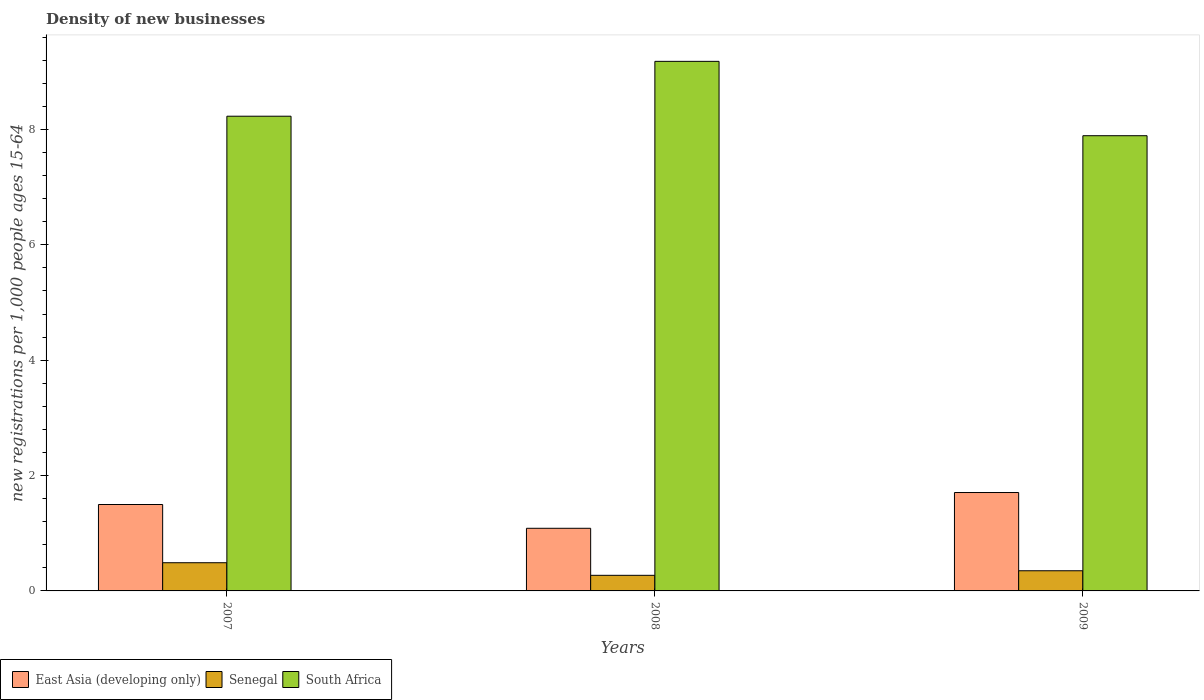How many groups of bars are there?
Offer a terse response. 3. Are the number of bars per tick equal to the number of legend labels?
Your answer should be compact. Yes. How many bars are there on the 3rd tick from the right?
Provide a succinct answer. 3. What is the label of the 3rd group of bars from the left?
Give a very brief answer. 2009. In how many cases, is the number of bars for a given year not equal to the number of legend labels?
Ensure brevity in your answer.  0. What is the number of new registrations in South Africa in 2007?
Keep it short and to the point. 8.23. Across all years, what is the maximum number of new registrations in Senegal?
Provide a short and direct response. 0.49. Across all years, what is the minimum number of new registrations in East Asia (developing only)?
Your answer should be very brief. 1.09. In which year was the number of new registrations in East Asia (developing only) maximum?
Give a very brief answer. 2009. What is the total number of new registrations in East Asia (developing only) in the graph?
Make the answer very short. 4.29. What is the difference between the number of new registrations in Senegal in 2008 and that in 2009?
Your answer should be very brief. -0.08. What is the difference between the number of new registrations in East Asia (developing only) in 2008 and the number of new registrations in Senegal in 2009?
Offer a terse response. 0.74. What is the average number of new registrations in East Asia (developing only) per year?
Provide a short and direct response. 1.43. In the year 2008, what is the difference between the number of new registrations in Senegal and number of new registrations in East Asia (developing only)?
Offer a terse response. -0.82. What is the ratio of the number of new registrations in South Africa in 2007 to that in 2008?
Your response must be concise. 0.9. Is the difference between the number of new registrations in Senegal in 2007 and 2008 greater than the difference between the number of new registrations in East Asia (developing only) in 2007 and 2008?
Ensure brevity in your answer.  No. What is the difference between the highest and the second highest number of new registrations in East Asia (developing only)?
Make the answer very short. 0.21. What is the difference between the highest and the lowest number of new registrations in East Asia (developing only)?
Your answer should be compact. 0.62. In how many years, is the number of new registrations in South Africa greater than the average number of new registrations in South Africa taken over all years?
Your response must be concise. 1. What does the 1st bar from the left in 2007 represents?
Your response must be concise. East Asia (developing only). What does the 3rd bar from the right in 2007 represents?
Provide a succinct answer. East Asia (developing only). Are all the bars in the graph horizontal?
Your answer should be compact. No. How many years are there in the graph?
Keep it short and to the point. 3. What is the difference between two consecutive major ticks on the Y-axis?
Provide a succinct answer. 2. Does the graph contain grids?
Provide a short and direct response. No. Where does the legend appear in the graph?
Provide a short and direct response. Bottom left. How many legend labels are there?
Provide a short and direct response. 3. What is the title of the graph?
Give a very brief answer. Density of new businesses. Does "Ukraine" appear as one of the legend labels in the graph?
Give a very brief answer. No. What is the label or title of the X-axis?
Give a very brief answer. Years. What is the label or title of the Y-axis?
Keep it short and to the point. New registrations per 1,0 people ages 15-64. What is the new registrations per 1,000 people ages 15-64 in East Asia (developing only) in 2007?
Give a very brief answer. 1.5. What is the new registrations per 1,000 people ages 15-64 in Senegal in 2007?
Provide a succinct answer. 0.49. What is the new registrations per 1,000 people ages 15-64 of South Africa in 2007?
Your answer should be compact. 8.23. What is the new registrations per 1,000 people ages 15-64 of East Asia (developing only) in 2008?
Provide a succinct answer. 1.09. What is the new registrations per 1,000 people ages 15-64 of Senegal in 2008?
Give a very brief answer. 0.27. What is the new registrations per 1,000 people ages 15-64 in South Africa in 2008?
Your answer should be very brief. 9.18. What is the new registrations per 1,000 people ages 15-64 of East Asia (developing only) in 2009?
Provide a succinct answer. 1.71. What is the new registrations per 1,000 people ages 15-64 of Senegal in 2009?
Keep it short and to the point. 0.35. What is the new registrations per 1,000 people ages 15-64 of South Africa in 2009?
Ensure brevity in your answer.  7.89. Across all years, what is the maximum new registrations per 1,000 people ages 15-64 in East Asia (developing only)?
Provide a short and direct response. 1.71. Across all years, what is the maximum new registrations per 1,000 people ages 15-64 in Senegal?
Keep it short and to the point. 0.49. Across all years, what is the maximum new registrations per 1,000 people ages 15-64 in South Africa?
Give a very brief answer. 9.18. Across all years, what is the minimum new registrations per 1,000 people ages 15-64 of East Asia (developing only)?
Your response must be concise. 1.09. Across all years, what is the minimum new registrations per 1,000 people ages 15-64 of Senegal?
Give a very brief answer. 0.27. Across all years, what is the minimum new registrations per 1,000 people ages 15-64 of South Africa?
Your answer should be compact. 7.89. What is the total new registrations per 1,000 people ages 15-64 in East Asia (developing only) in the graph?
Your answer should be very brief. 4.29. What is the total new registrations per 1,000 people ages 15-64 of Senegal in the graph?
Give a very brief answer. 1.11. What is the total new registrations per 1,000 people ages 15-64 in South Africa in the graph?
Make the answer very short. 25.3. What is the difference between the new registrations per 1,000 people ages 15-64 of East Asia (developing only) in 2007 and that in 2008?
Your response must be concise. 0.41. What is the difference between the new registrations per 1,000 people ages 15-64 of Senegal in 2007 and that in 2008?
Offer a very short reply. 0.22. What is the difference between the new registrations per 1,000 people ages 15-64 of South Africa in 2007 and that in 2008?
Your answer should be compact. -0.95. What is the difference between the new registrations per 1,000 people ages 15-64 in East Asia (developing only) in 2007 and that in 2009?
Offer a very short reply. -0.21. What is the difference between the new registrations per 1,000 people ages 15-64 in Senegal in 2007 and that in 2009?
Your answer should be very brief. 0.14. What is the difference between the new registrations per 1,000 people ages 15-64 of South Africa in 2007 and that in 2009?
Provide a succinct answer. 0.34. What is the difference between the new registrations per 1,000 people ages 15-64 of East Asia (developing only) in 2008 and that in 2009?
Ensure brevity in your answer.  -0.62. What is the difference between the new registrations per 1,000 people ages 15-64 of Senegal in 2008 and that in 2009?
Give a very brief answer. -0.08. What is the difference between the new registrations per 1,000 people ages 15-64 in South Africa in 2008 and that in 2009?
Provide a short and direct response. 1.29. What is the difference between the new registrations per 1,000 people ages 15-64 of East Asia (developing only) in 2007 and the new registrations per 1,000 people ages 15-64 of Senegal in 2008?
Your answer should be compact. 1.23. What is the difference between the new registrations per 1,000 people ages 15-64 of East Asia (developing only) in 2007 and the new registrations per 1,000 people ages 15-64 of South Africa in 2008?
Ensure brevity in your answer.  -7.68. What is the difference between the new registrations per 1,000 people ages 15-64 in Senegal in 2007 and the new registrations per 1,000 people ages 15-64 in South Africa in 2008?
Provide a short and direct response. -8.69. What is the difference between the new registrations per 1,000 people ages 15-64 of East Asia (developing only) in 2007 and the new registrations per 1,000 people ages 15-64 of Senegal in 2009?
Offer a terse response. 1.15. What is the difference between the new registrations per 1,000 people ages 15-64 in East Asia (developing only) in 2007 and the new registrations per 1,000 people ages 15-64 in South Africa in 2009?
Keep it short and to the point. -6.39. What is the difference between the new registrations per 1,000 people ages 15-64 of Senegal in 2007 and the new registrations per 1,000 people ages 15-64 of South Africa in 2009?
Your answer should be compact. -7.4. What is the difference between the new registrations per 1,000 people ages 15-64 of East Asia (developing only) in 2008 and the new registrations per 1,000 people ages 15-64 of Senegal in 2009?
Keep it short and to the point. 0.74. What is the difference between the new registrations per 1,000 people ages 15-64 in East Asia (developing only) in 2008 and the new registrations per 1,000 people ages 15-64 in South Africa in 2009?
Give a very brief answer. -6.81. What is the difference between the new registrations per 1,000 people ages 15-64 of Senegal in 2008 and the new registrations per 1,000 people ages 15-64 of South Africa in 2009?
Provide a short and direct response. -7.62. What is the average new registrations per 1,000 people ages 15-64 of East Asia (developing only) per year?
Provide a short and direct response. 1.43. What is the average new registrations per 1,000 people ages 15-64 of Senegal per year?
Ensure brevity in your answer.  0.37. What is the average new registrations per 1,000 people ages 15-64 of South Africa per year?
Your answer should be very brief. 8.43. In the year 2007, what is the difference between the new registrations per 1,000 people ages 15-64 of East Asia (developing only) and new registrations per 1,000 people ages 15-64 of Senegal?
Ensure brevity in your answer.  1.01. In the year 2007, what is the difference between the new registrations per 1,000 people ages 15-64 in East Asia (developing only) and new registrations per 1,000 people ages 15-64 in South Africa?
Offer a terse response. -6.73. In the year 2007, what is the difference between the new registrations per 1,000 people ages 15-64 in Senegal and new registrations per 1,000 people ages 15-64 in South Africa?
Offer a very short reply. -7.74. In the year 2008, what is the difference between the new registrations per 1,000 people ages 15-64 of East Asia (developing only) and new registrations per 1,000 people ages 15-64 of Senegal?
Give a very brief answer. 0.82. In the year 2008, what is the difference between the new registrations per 1,000 people ages 15-64 of East Asia (developing only) and new registrations per 1,000 people ages 15-64 of South Africa?
Provide a succinct answer. -8.09. In the year 2008, what is the difference between the new registrations per 1,000 people ages 15-64 in Senegal and new registrations per 1,000 people ages 15-64 in South Africa?
Give a very brief answer. -8.91. In the year 2009, what is the difference between the new registrations per 1,000 people ages 15-64 in East Asia (developing only) and new registrations per 1,000 people ages 15-64 in Senegal?
Your answer should be compact. 1.36. In the year 2009, what is the difference between the new registrations per 1,000 people ages 15-64 of East Asia (developing only) and new registrations per 1,000 people ages 15-64 of South Africa?
Offer a terse response. -6.19. In the year 2009, what is the difference between the new registrations per 1,000 people ages 15-64 of Senegal and new registrations per 1,000 people ages 15-64 of South Africa?
Offer a very short reply. -7.54. What is the ratio of the new registrations per 1,000 people ages 15-64 in East Asia (developing only) in 2007 to that in 2008?
Keep it short and to the point. 1.38. What is the ratio of the new registrations per 1,000 people ages 15-64 of Senegal in 2007 to that in 2008?
Provide a short and direct response. 1.81. What is the ratio of the new registrations per 1,000 people ages 15-64 of South Africa in 2007 to that in 2008?
Your answer should be very brief. 0.9. What is the ratio of the new registrations per 1,000 people ages 15-64 of East Asia (developing only) in 2007 to that in 2009?
Provide a succinct answer. 0.88. What is the ratio of the new registrations per 1,000 people ages 15-64 of Senegal in 2007 to that in 2009?
Keep it short and to the point. 1.4. What is the ratio of the new registrations per 1,000 people ages 15-64 of South Africa in 2007 to that in 2009?
Offer a very short reply. 1.04. What is the ratio of the new registrations per 1,000 people ages 15-64 in East Asia (developing only) in 2008 to that in 2009?
Your response must be concise. 0.64. What is the ratio of the new registrations per 1,000 people ages 15-64 of Senegal in 2008 to that in 2009?
Offer a terse response. 0.77. What is the ratio of the new registrations per 1,000 people ages 15-64 of South Africa in 2008 to that in 2009?
Make the answer very short. 1.16. What is the difference between the highest and the second highest new registrations per 1,000 people ages 15-64 of East Asia (developing only)?
Provide a succinct answer. 0.21. What is the difference between the highest and the second highest new registrations per 1,000 people ages 15-64 in Senegal?
Your response must be concise. 0.14. What is the difference between the highest and the second highest new registrations per 1,000 people ages 15-64 in South Africa?
Provide a short and direct response. 0.95. What is the difference between the highest and the lowest new registrations per 1,000 people ages 15-64 of East Asia (developing only)?
Make the answer very short. 0.62. What is the difference between the highest and the lowest new registrations per 1,000 people ages 15-64 of Senegal?
Make the answer very short. 0.22. What is the difference between the highest and the lowest new registrations per 1,000 people ages 15-64 of South Africa?
Your answer should be very brief. 1.29. 